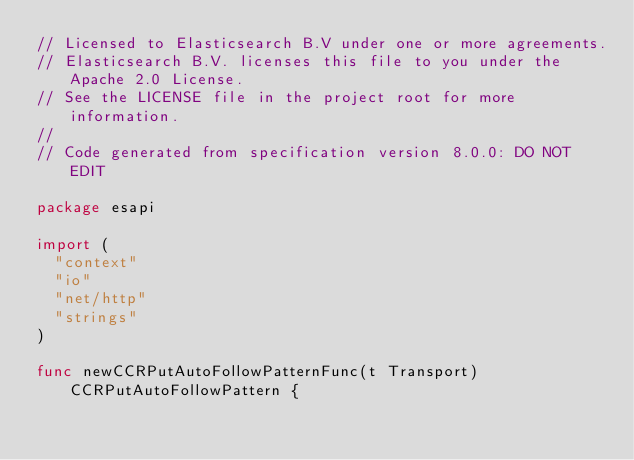<code> <loc_0><loc_0><loc_500><loc_500><_Go_>// Licensed to Elasticsearch B.V under one or more agreements.
// Elasticsearch B.V. licenses this file to you under the Apache 2.0 License.
// See the LICENSE file in the project root for more information.
//
// Code generated from specification version 8.0.0: DO NOT EDIT

package esapi

import (
	"context"
	"io"
	"net/http"
	"strings"
)

func newCCRPutAutoFollowPatternFunc(t Transport) CCRPutAutoFollowPattern {</code> 